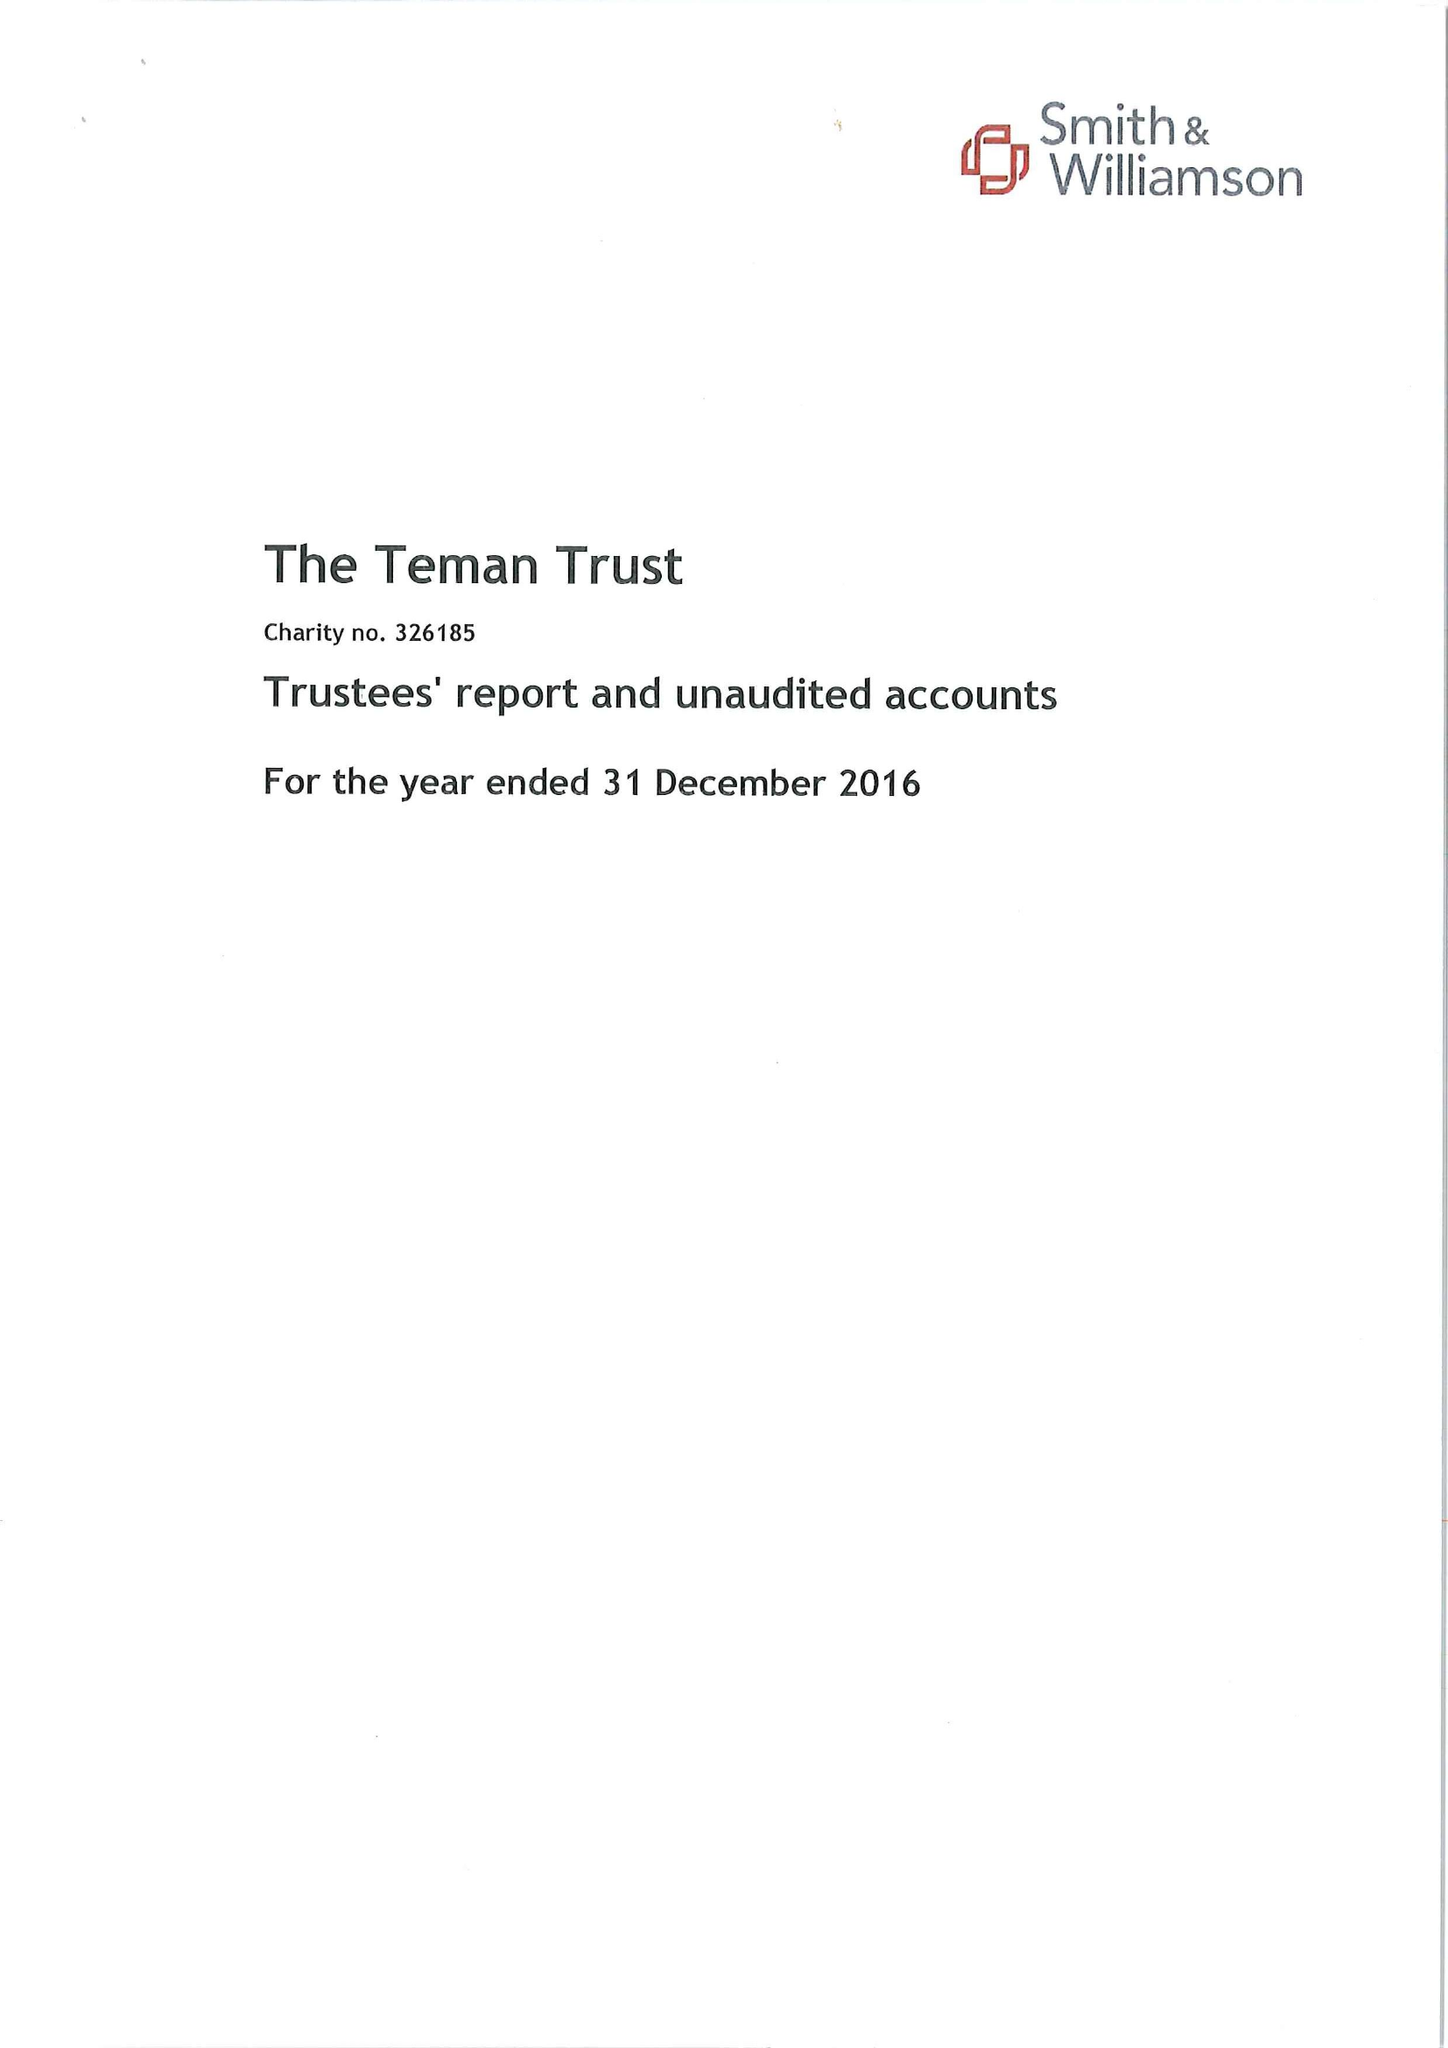What is the value for the charity_number?
Answer the question using a single word or phrase. 326185 